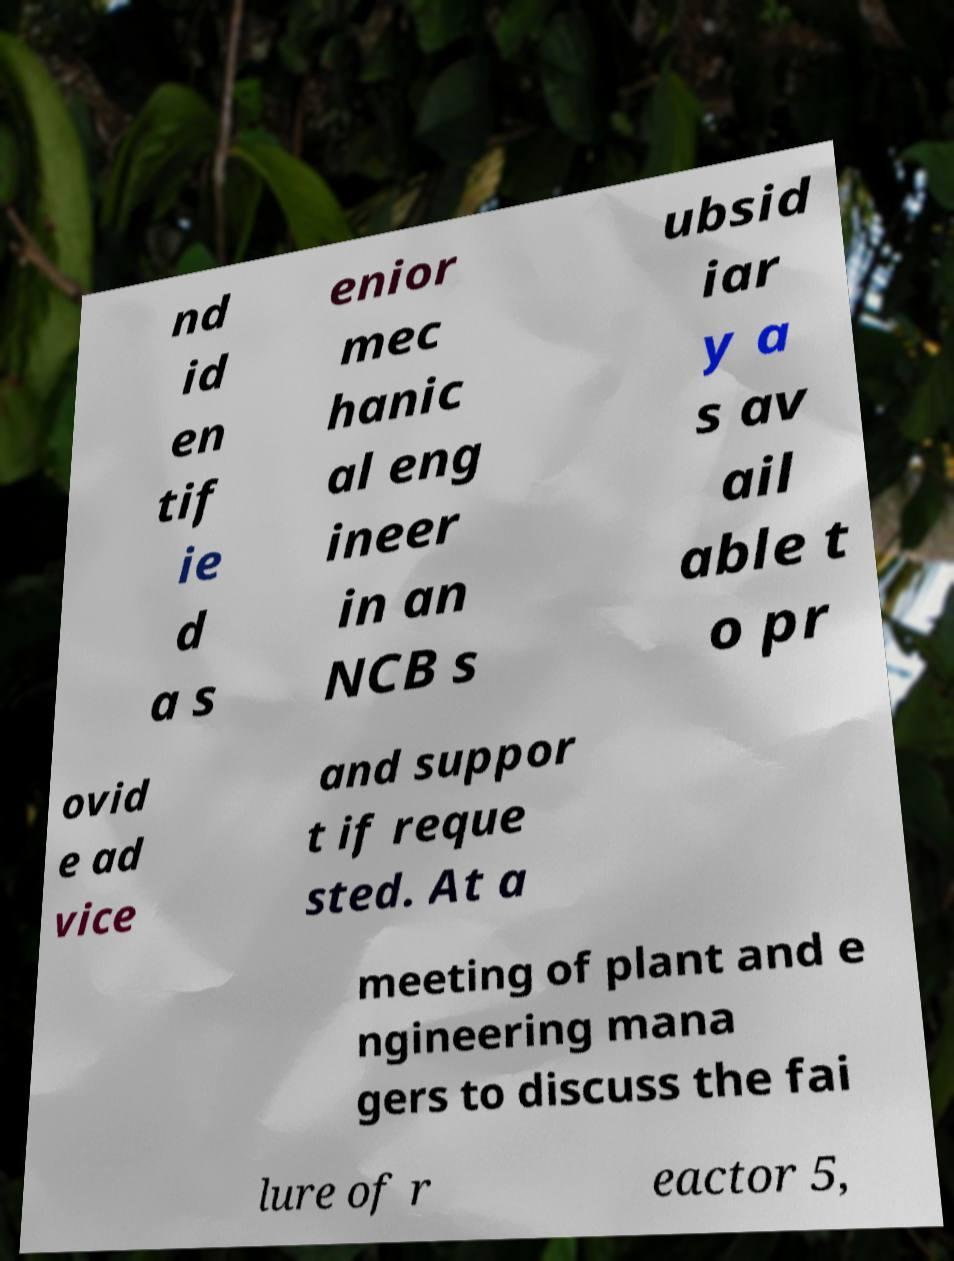Please identify and transcribe the text found in this image. nd id en tif ie d a s enior mec hanic al eng ineer in an NCB s ubsid iar y a s av ail able t o pr ovid e ad vice and suppor t if reque sted. At a meeting of plant and e ngineering mana gers to discuss the fai lure of r eactor 5, 